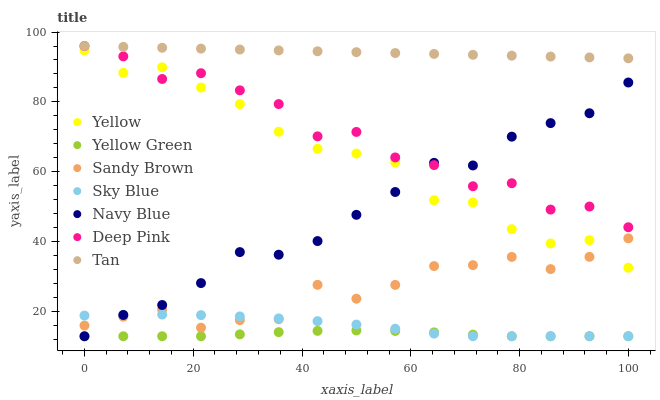Does Yellow Green have the minimum area under the curve?
Answer yes or no. Yes. Does Tan have the maximum area under the curve?
Answer yes or no. Yes. Does Navy Blue have the minimum area under the curve?
Answer yes or no. No. Does Navy Blue have the maximum area under the curve?
Answer yes or no. No. Is Tan the smoothest?
Answer yes or no. Yes. Is Deep Pink the roughest?
Answer yes or no. Yes. Is Yellow Green the smoothest?
Answer yes or no. No. Is Yellow Green the roughest?
Answer yes or no. No. Does Yellow Green have the lowest value?
Answer yes or no. Yes. Does Yellow have the lowest value?
Answer yes or no. No. Does Tan have the highest value?
Answer yes or no. Yes. Does Navy Blue have the highest value?
Answer yes or no. No. Is Sandy Brown less than Deep Pink?
Answer yes or no. Yes. Is Tan greater than Yellow?
Answer yes or no. Yes. Does Deep Pink intersect Tan?
Answer yes or no. Yes. Is Deep Pink less than Tan?
Answer yes or no. No. Is Deep Pink greater than Tan?
Answer yes or no. No. Does Sandy Brown intersect Deep Pink?
Answer yes or no. No. 